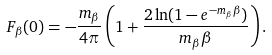<formula> <loc_0><loc_0><loc_500><loc_500>F _ { \beta } ( 0 ) = - \frac { m _ { \beta } } { 4 \pi } \left ( 1 + \frac { 2 \ln ( 1 - e ^ { - m _ { \beta } \beta } ) } { m _ { \beta } \beta } \right ) .</formula> 